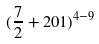<formula> <loc_0><loc_0><loc_500><loc_500>( \frac { 7 } { 2 } + 2 0 1 ) ^ { 4 - 9 }</formula> 